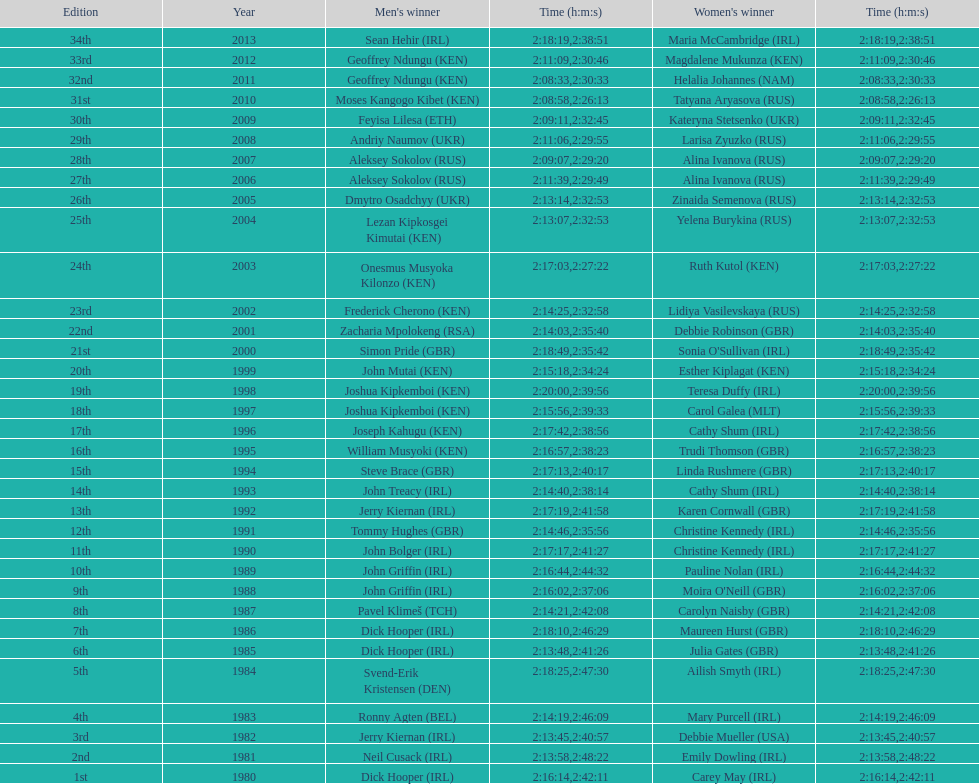In 2009, who completed the race quicker - the male participant or the female participant? Male. 